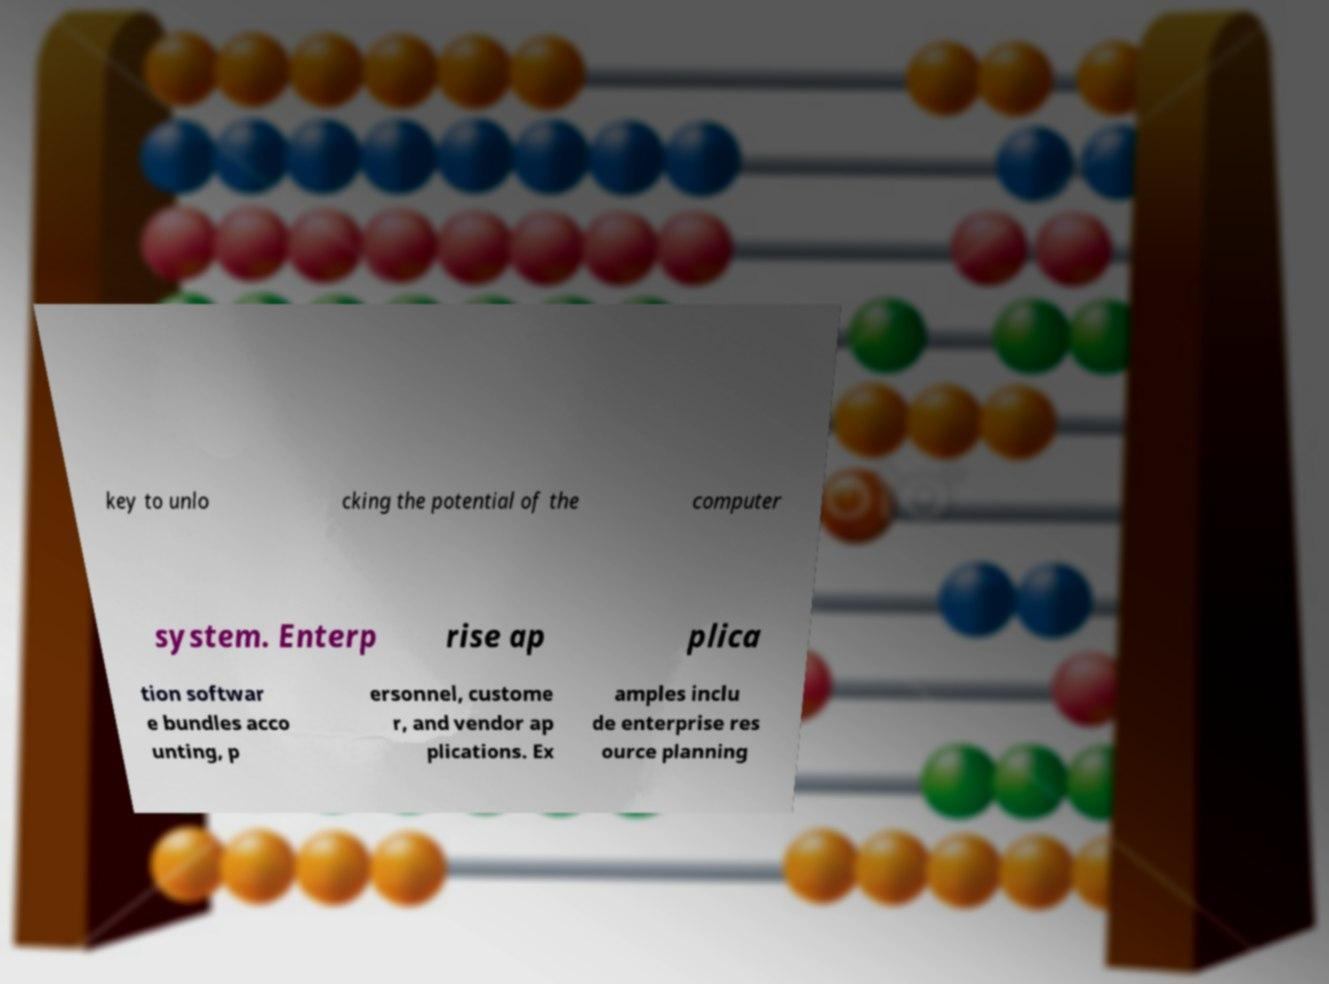Please read and relay the text visible in this image. What does it say? key to unlo cking the potential of the computer system. Enterp rise ap plica tion softwar e bundles acco unting, p ersonnel, custome r, and vendor ap plications. Ex amples inclu de enterprise res ource planning 